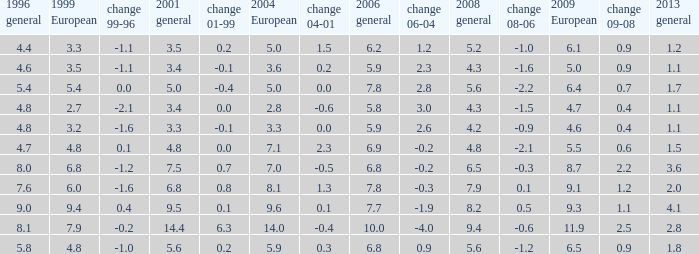What is the lowest value for 2004 European when 1999 European is 3.3 and less than 4.4 in 1996 general? None. 